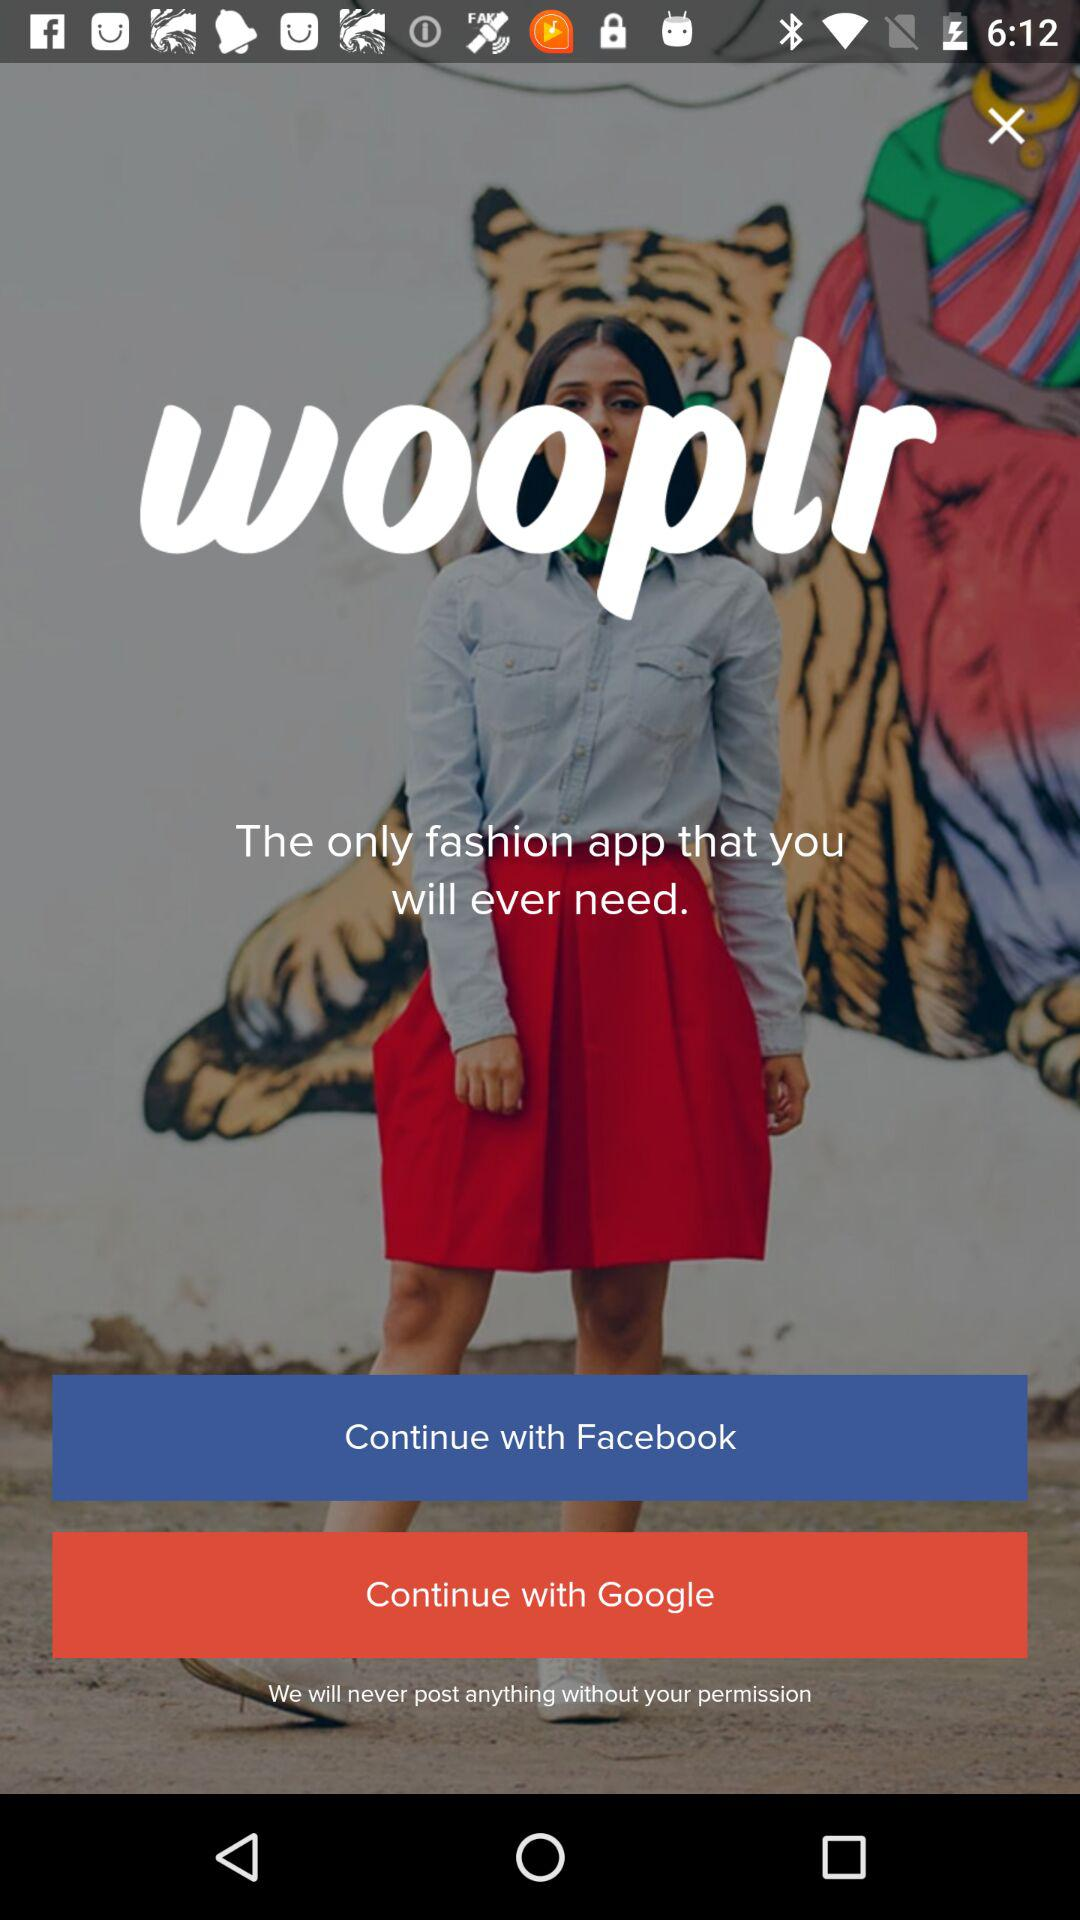What is the application name? The application name is "wooplr". 